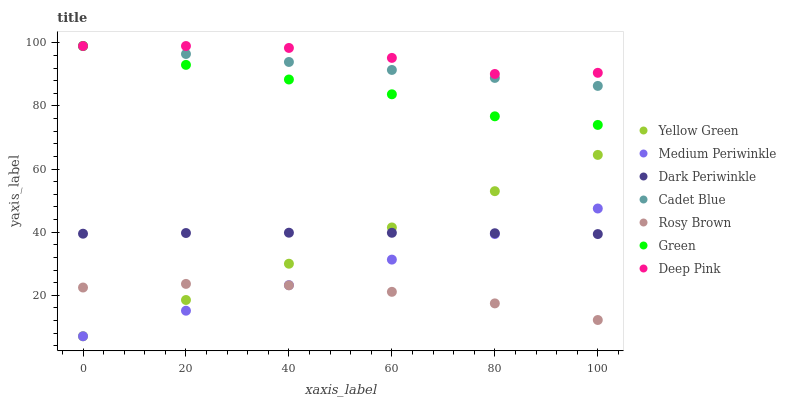Does Rosy Brown have the minimum area under the curve?
Answer yes or no. Yes. Does Deep Pink have the maximum area under the curve?
Answer yes or no. Yes. Does Yellow Green have the minimum area under the curve?
Answer yes or no. No. Does Yellow Green have the maximum area under the curve?
Answer yes or no. No. Is Yellow Green the smoothest?
Answer yes or no. Yes. Is Deep Pink the roughest?
Answer yes or no. Yes. Is Rosy Brown the smoothest?
Answer yes or no. No. Is Rosy Brown the roughest?
Answer yes or no. No. Does Yellow Green have the lowest value?
Answer yes or no. Yes. Does Rosy Brown have the lowest value?
Answer yes or no. No. Does Green have the highest value?
Answer yes or no. Yes. Does Yellow Green have the highest value?
Answer yes or no. No. Is Medium Periwinkle less than Deep Pink?
Answer yes or no. Yes. Is Green greater than Dark Periwinkle?
Answer yes or no. Yes. Does Dark Periwinkle intersect Yellow Green?
Answer yes or no. Yes. Is Dark Periwinkle less than Yellow Green?
Answer yes or no. No. Is Dark Periwinkle greater than Yellow Green?
Answer yes or no. No. Does Medium Periwinkle intersect Deep Pink?
Answer yes or no. No. 